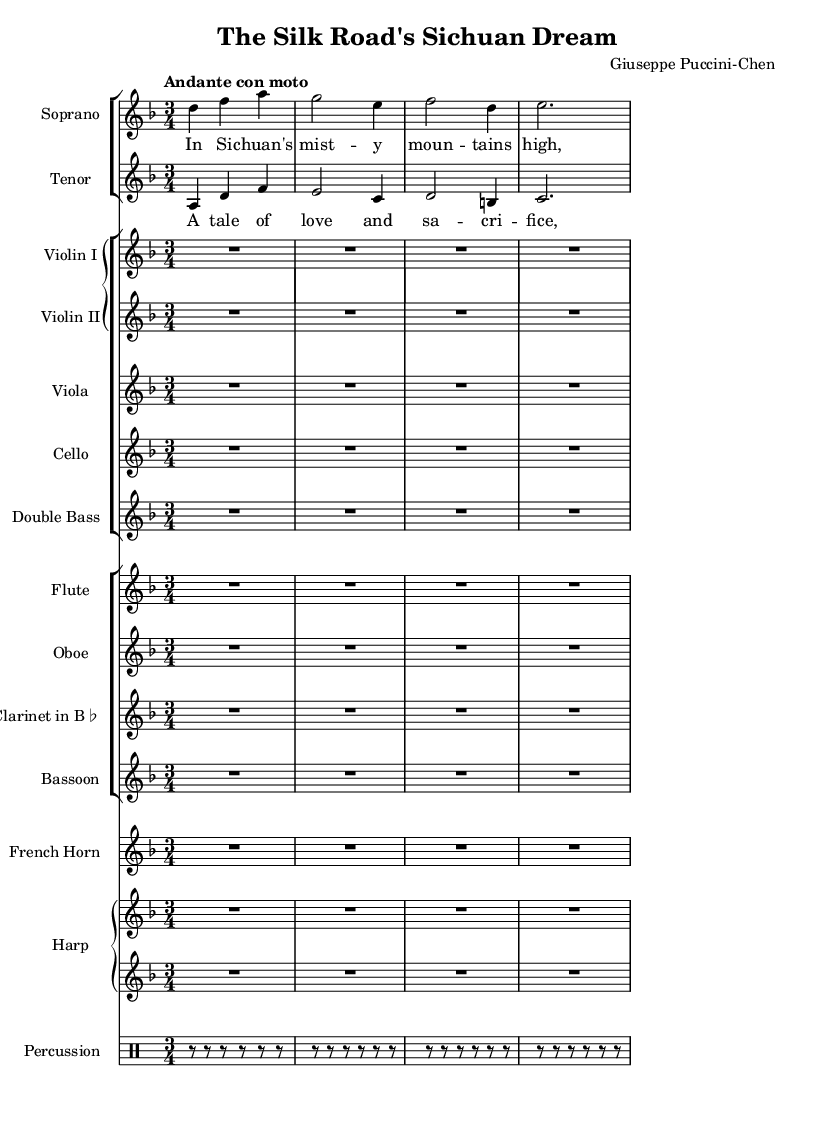What is the key signature of this music? The key signature is indicated at the beginning of the sheet music. Here, it is a D minor key signature, which typically has one flat (B flat).
Answer: D minor What is the time signature of this music? The time signature is found directly after the key signature in the score. In this case, it shows 3/4, indicating a waltz-like rhythm with three beats per measure.
Answer: 3/4 What is the tempo of this piece? The tempo marking is included in the global settings of the score. It specifies "Andante con moto," which suggests a moderately slow pace with some movement.
Answer: Andante con moto How many instruments are featured in the score? By counting the unique staff groups listed in the score, there are 10 separate instruments or groups present in the rendered music, including strings and woodwinds.
Answer: 10 What are the voice parts included in the music? The score explicitly separates the vocal parts into their respective staves, which are labeled "Soprano" and "Tenor." Therefore, the vocal parts featured are these two types.
Answer: Soprano and Tenor What is the title of the opera? The title is found in the header section of the score, where it is clearly stated as "The Silk Road's Sichuan Dream." This provides cultural context regarding the narrative setting of the opera.
Answer: The Silk Road's Sichuan Dream Who is the composer of this opera? The composer's name is listed in the header of the score next to the title. In this case, the composer is "Giuseppe Puccini-Chen," which gives insight into the influences on the music.
Answer: Giuseppe Puccini-Chen 